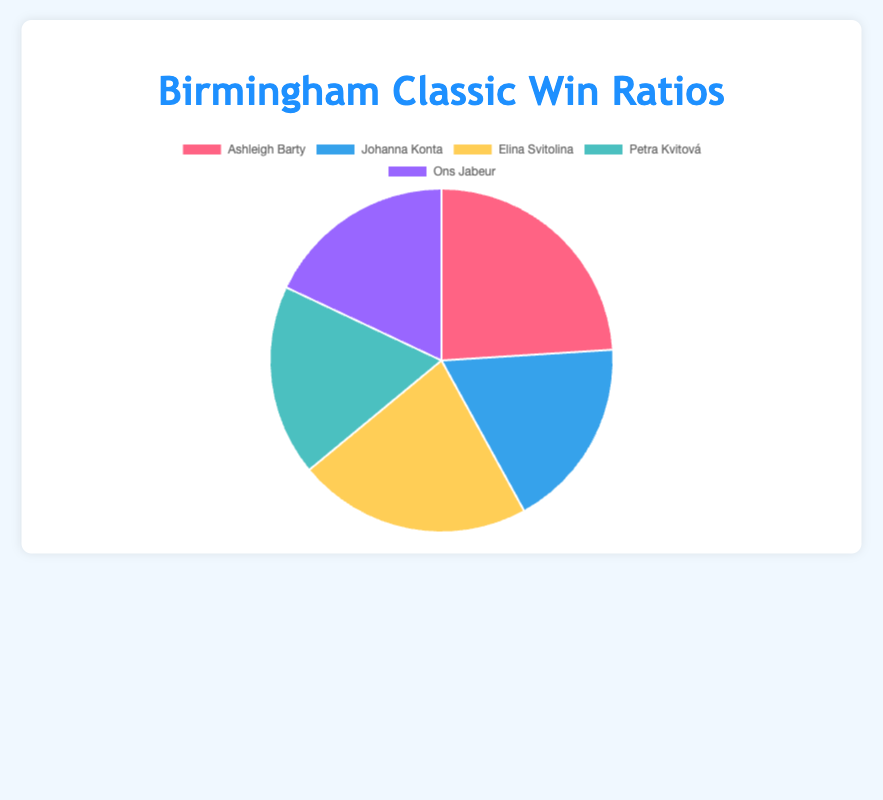What's the win ratio for Ashleigh Barty? The chart shows that Ashleigh Barty has a win ratio of 24.
Answer: 24 Which player has the highest win ratio? Among the players, Ashleigh Barty has the highest win ratio with 24, followed closely by Elina Svitolina with 22.
Answer: Ashleigh Barty Which players have the same win ratio? The players with the same win ratio are Johanna Konta, Petra Kvitová, and Ons Jabeur, each having a win ratio of 18.
Answer: Johanna Konta, Petra Kvitová, Ons Jabeur What is the difference in win ratio between Ashleigh Barty and Elina Svitolina? Ashleigh Barty has a win ratio of 24 and Elina Svitolina has a win ratio of 22. The difference is 24 - 22 = 2.
Answer: 2 What's the average win ratio of all five players combined? To calculate the average, sum the win ratios (24 + 18 + 22 + 18 + 18 = 100) and divide by the number of players (100 / 5).
Answer: 20 Which player has the smallest win ratio? According to the chart, Johanna Konta, Petra Kvitová, and Ons Jabeur each have the smallest win ratio, which is 18.
Answer: Johanna Konta, Petra Kvitová, Ons Jabeur Compare the win ratio of Elina Svitolina and Petra Kvitová. Elina Svitolina has a win ratio of 22, while Petra Kvitová has a win ratio of 18. Therefore, Elina Svitolina's win ratio is higher.
Answer: Elina Svitolina How many players have a win ratio less than 20? By examining the chart, Johanna Konta, Petra Kvitová, and Ons Jabeur each have a win ratio of 18, which is less than 20.
Answer: 3 players 